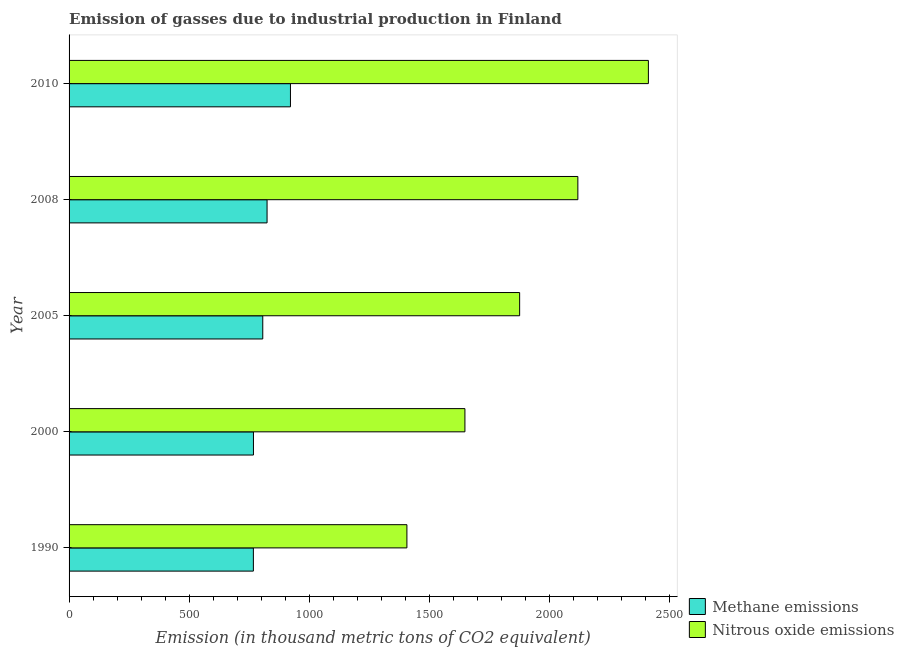How many different coloured bars are there?
Your answer should be compact. 2. How many groups of bars are there?
Your answer should be very brief. 5. Are the number of bars on each tick of the Y-axis equal?
Offer a terse response. Yes. What is the label of the 4th group of bars from the top?
Keep it short and to the point. 2000. What is the amount of methane emissions in 2010?
Offer a very short reply. 921.9. Across all years, what is the maximum amount of methane emissions?
Your answer should be very brief. 921.9. Across all years, what is the minimum amount of nitrous oxide emissions?
Your response must be concise. 1406.8. What is the total amount of nitrous oxide emissions in the graph?
Your response must be concise. 9462.6. What is the difference between the amount of methane emissions in 2000 and that in 2010?
Provide a short and direct response. -154.1. What is the difference between the amount of methane emissions in 2000 and the amount of nitrous oxide emissions in 2008?
Provide a succinct answer. -1350.9. What is the average amount of methane emissions per year?
Ensure brevity in your answer.  817.66. In the year 2008, what is the difference between the amount of nitrous oxide emissions and amount of methane emissions?
Keep it short and to the point. 1294.2. Is the amount of nitrous oxide emissions in 1990 less than that in 2008?
Offer a very short reply. Yes. Is the difference between the amount of methane emissions in 1990 and 2008 greater than the difference between the amount of nitrous oxide emissions in 1990 and 2008?
Give a very brief answer. Yes. What is the difference between the highest and the second highest amount of nitrous oxide emissions?
Your answer should be compact. 293.7. What is the difference between the highest and the lowest amount of methane emissions?
Give a very brief answer. 154.4. What does the 2nd bar from the top in 2008 represents?
Make the answer very short. Methane emissions. What does the 1st bar from the bottom in 2010 represents?
Offer a very short reply. Methane emissions. How many years are there in the graph?
Your answer should be compact. 5. Does the graph contain grids?
Give a very brief answer. No. Where does the legend appear in the graph?
Ensure brevity in your answer.  Bottom right. How are the legend labels stacked?
Your answer should be compact. Vertical. What is the title of the graph?
Offer a very short reply. Emission of gasses due to industrial production in Finland. What is the label or title of the X-axis?
Your response must be concise. Emission (in thousand metric tons of CO2 equivalent). What is the Emission (in thousand metric tons of CO2 equivalent) in Methane emissions in 1990?
Ensure brevity in your answer.  767.5. What is the Emission (in thousand metric tons of CO2 equivalent) in Nitrous oxide emissions in 1990?
Provide a succinct answer. 1406.8. What is the Emission (in thousand metric tons of CO2 equivalent) in Methane emissions in 2000?
Ensure brevity in your answer.  767.8. What is the Emission (in thousand metric tons of CO2 equivalent) of Nitrous oxide emissions in 2000?
Offer a very short reply. 1648.4. What is the Emission (in thousand metric tons of CO2 equivalent) of Methane emissions in 2005?
Provide a succinct answer. 806.6. What is the Emission (in thousand metric tons of CO2 equivalent) in Nitrous oxide emissions in 2005?
Your response must be concise. 1876.3. What is the Emission (in thousand metric tons of CO2 equivalent) of Methane emissions in 2008?
Provide a succinct answer. 824.5. What is the Emission (in thousand metric tons of CO2 equivalent) of Nitrous oxide emissions in 2008?
Offer a very short reply. 2118.7. What is the Emission (in thousand metric tons of CO2 equivalent) of Methane emissions in 2010?
Ensure brevity in your answer.  921.9. What is the Emission (in thousand metric tons of CO2 equivalent) of Nitrous oxide emissions in 2010?
Your response must be concise. 2412.4. Across all years, what is the maximum Emission (in thousand metric tons of CO2 equivalent) in Methane emissions?
Ensure brevity in your answer.  921.9. Across all years, what is the maximum Emission (in thousand metric tons of CO2 equivalent) in Nitrous oxide emissions?
Offer a very short reply. 2412.4. Across all years, what is the minimum Emission (in thousand metric tons of CO2 equivalent) of Methane emissions?
Make the answer very short. 767.5. Across all years, what is the minimum Emission (in thousand metric tons of CO2 equivalent) of Nitrous oxide emissions?
Keep it short and to the point. 1406.8. What is the total Emission (in thousand metric tons of CO2 equivalent) of Methane emissions in the graph?
Make the answer very short. 4088.3. What is the total Emission (in thousand metric tons of CO2 equivalent) in Nitrous oxide emissions in the graph?
Your response must be concise. 9462.6. What is the difference between the Emission (in thousand metric tons of CO2 equivalent) of Nitrous oxide emissions in 1990 and that in 2000?
Offer a very short reply. -241.6. What is the difference between the Emission (in thousand metric tons of CO2 equivalent) in Methane emissions in 1990 and that in 2005?
Give a very brief answer. -39.1. What is the difference between the Emission (in thousand metric tons of CO2 equivalent) of Nitrous oxide emissions in 1990 and that in 2005?
Offer a terse response. -469.5. What is the difference between the Emission (in thousand metric tons of CO2 equivalent) in Methane emissions in 1990 and that in 2008?
Offer a very short reply. -57. What is the difference between the Emission (in thousand metric tons of CO2 equivalent) of Nitrous oxide emissions in 1990 and that in 2008?
Your answer should be compact. -711.9. What is the difference between the Emission (in thousand metric tons of CO2 equivalent) of Methane emissions in 1990 and that in 2010?
Provide a short and direct response. -154.4. What is the difference between the Emission (in thousand metric tons of CO2 equivalent) in Nitrous oxide emissions in 1990 and that in 2010?
Offer a terse response. -1005.6. What is the difference between the Emission (in thousand metric tons of CO2 equivalent) of Methane emissions in 2000 and that in 2005?
Offer a very short reply. -38.8. What is the difference between the Emission (in thousand metric tons of CO2 equivalent) of Nitrous oxide emissions in 2000 and that in 2005?
Ensure brevity in your answer.  -227.9. What is the difference between the Emission (in thousand metric tons of CO2 equivalent) in Methane emissions in 2000 and that in 2008?
Make the answer very short. -56.7. What is the difference between the Emission (in thousand metric tons of CO2 equivalent) of Nitrous oxide emissions in 2000 and that in 2008?
Offer a terse response. -470.3. What is the difference between the Emission (in thousand metric tons of CO2 equivalent) of Methane emissions in 2000 and that in 2010?
Make the answer very short. -154.1. What is the difference between the Emission (in thousand metric tons of CO2 equivalent) in Nitrous oxide emissions in 2000 and that in 2010?
Your response must be concise. -764. What is the difference between the Emission (in thousand metric tons of CO2 equivalent) in Methane emissions in 2005 and that in 2008?
Offer a very short reply. -17.9. What is the difference between the Emission (in thousand metric tons of CO2 equivalent) in Nitrous oxide emissions in 2005 and that in 2008?
Provide a short and direct response. -242.4. What is the difference between the Emission (in thousand metric tons of CO2 equivalent) of Methane emissions in 2005 and that in 2010?
Your answer should be very brief. -115.3. What is the difference between the Emission (in thousand metric tons of CO2 equivalent) of Nitrous oxide emissions in 2005 and that in 2010?
Offer a very short reply. -536.1. What is the difference between the Emission (in thousand metric tons of CO2 equivalent) in Methane emissions in 2008 and that in 2010?
Give a very brief answer. -97.4. What is the difference between the Emission (in thousand metric tons of CO2 equivalent) in Nitrous oxide emissions in 2008 and that in 2010?
Offer a very short reply. -293.7. What is the difference between the Emission (in thousand metric tons of CO2 equivalent) in Methane emissions in 1990 and the Emission (in thousand metric tons of CO2 equivalent) in Nitrous oxide emissions in 2000?
Make the answer very short. -880.9. What is the difference between the Emission (in thousand metric tons of CO2 equivalent) in Methane emissions in 1990 and the Emission (in thousand metric tons of CO2 equivalent) in Nitrous oxide emissions in 2005?
Make the answer very short. -1108.8. What is the difference between the Emission (in thousand metric tons of CO2 equivalent) in Methane emissions in 1990 and the Emission (in thousand metric tons of CO2 equivalent) in Nitrous oxide emissions in 2008?
Give a very brief answer. -1351.2. What is the difference between the Emission (in thousand metric tons of CO2 equivalent) of Methane emissions in 1990 and the Emission (in thousand metric tons of CO2 equivalent) of Nitrous oxide emissions in 2010?
Provide a short and direct response. -1644.9. What is the difference between the Emission (in thousand metric tons of CO2 equivalent) of Methane emissions in 2000 and the Emission (in thousand metric tons of CO2 equivalent) of Nitrous oxide emissions in 2005?
Offer a very short reply. -1108.5. What is the difference between the Emission (in thousand metric tons of CO2 equivalent) in Methane emissions in 2000 and the Emission (in thousand metric tons of CO2 equivalent) in Nitrous oxide emissions in 2008?
Your answer should be very brief. -1350.9. What is the difference between the Emission (in thousand metric tons of CO2 equivalent) of Methane emissions in 2000 and the Emission (in thousand metric tons of CO2 equivalent) of Nitrous oxide emissions in 2010?
Make the answer very short. -1644.6. What is the difference between the Emission (in thousand metric tons of CO2 equivalent) in Methane emissions in 2005 and the Emission (in thousand metric tons of CO2 equivalent) in Nitrous oxide emissions in 2008?
Provide a short and direct response. -1312.1. What is the difference between the Emission (in thousand metric tons of CO2 equivalent) in Methane emissions in 2005 and the Emission (in thousand metric tons of CO2 equivalent) in Nitrous oxide emissions in 2010?
Your answer should be compact. -1605.8. What is the difference between the Emission (in thousand metric tons of CO2 equivalent) in Methane emissions in 2008 and the Emission (in thousand metric tons of CO2 equivalent) in Nitrous oxide emissions in 2010?
Your answer should be compact. -1587.9. What is the average Emission (in thousand metric tons of CO2 equivalent) of Methane emissions per year?
Offer a very short reply. 817.66. What is the average Emission (in thousand metric tons of CO2 equivalent) of Nitrous oxide emissions per year?
Provide a short and direct response. 1892.52. In the year 1990, what is the difference between the Emission (in thousand metric tons of CO2 equivalent) in Methane emissions and Emission (in thousand metric tons of CO2 equivalent) in Nitrous oxide emissions?
Keep it short and to the point. -639.3. In the year 2000, what is the difference between the Emission (in thousand metric tons of CO2 equivalent) of Methane emissions and Emission (in thousand metric tons of CO2 equivalent) of Nitrous oxide emissions?
Your answer should be very brief. -880.6. In the year 2005, what is the difference between the Emission (in thousand metric tons of CO2 equivalent) of Methane emissions and Emission (in thousand metric tons of CO2 equivalent) of Nitrous oxide emissions?
Provide a short and direct response. -1069.7. In the year 2008, what is the difference between the Emission (in thousand metric tons of CO2 equivalent) of Methane emissions and Emission (in thousand metric tons of CO2 equivalent) of Nitrous oxide emissions?
Your answer should be very brief. -1294.2. In the year 2010, what is the difference between the Emission (in thousand metric tons of CO2 equivalent) of Methane emissions and Emission (in thousand metric tons of CO2 equivalent) of Nitrous oxide emissions?
Your answer should be compact. -1490.5. What is the ratio of the Emission (in thousand metric tons of CO2 equivalent) in Nitrous oxide emissions in 1990 to that in 2000?
Your answer should be compact. 0.85. What is the ratio of the Emission (in thousand metric tons of CO2 equivalent) of Methane emissions in 1990 to that in 2005?
Your answer should be compact. 0.95. What is the ratio of the Emission (in thousand metric tons of CO2 equivalent) of Nitrous oxide emissions in 1990 to that in 2005?
Keep it short and to the point. 0.75. What is the ratio of the Emission (in thousand metric tons of CO2 equivalent) in Methane emissions in 1990 to that in 2008?
Offer a very short reply. 0.93. What is the ratio of the Emission (in thousand metric tons of CO2 equivalent) in Nitrous oxide emissions in 1990 to that in 2008?
Make the answer very short. 0.66. What is the ratio of the Emission (in thousand metric tons of CO2 equivalent) in Methane emissions in 1990 to that in 2010?
Provide a short and direct response. 0.83. What is the ratio of the Emission (in thousand metric tons of CO2 equivalent) of Nitrous oxide emissions in 1990 to that in 2010?
Provide a short and direct response. 0.58. What is the ratio of the Emission (in thousand metric tons of CO2 equivalent) of Methane emissions in 2000 to that in 2005?
Ensure brevity in your answer.  0.95. What is the ratio of the Emission (in thousand metric tons of CO2 equivalent) in Nitrous oxide emissions in 2000 to that in 2005?
Provide a succinct answer. 0.88. What is the ratio of the Emission (in thousand metric tons of CO2 equivalent) of Methane emissions in 2000 to that in 2008?
Provide a short and direct response. 0.93. What is the ratio of the Emission (in thousand metric tons of CO2 equivalent) of Nitrous oxide emissions in 2000 to that in 2008?
Make the answer very short. 0.78. What is the ratio of the Emission (in thousand metric tons of CO2 equivalent) of Methane emissions in 2000 to that in 2010?
Ensure brevity in your answer.  0.83. What is the ratio of the Emission (in thousand metric tons of CO2 equivalent) of Nitrous oxide emissions in 2000 to that in 2010?
Your answer should be compact. 0.68. What is the ratio of the Emission (in thousand metric tons of CO2 equivalent) in Methane emissions in 2005 to that in 2008?
Keep it short and to the point. 0.98. What is the ratio of the Emission (in thousand metric tons of CO2 equivalent) in Nitrous oxide emissions in 2005 to that in 2008?
Give a very brief answer. 0.89. What is the ratio of the Emission (in thousand metric tons of CO2 equivalent) in Methane emissions in 2005 to that in 2010?
Provide a short and direct response. 0.87. What is the ratio of the Emission (in thousand metric tons of CO2 equivalent) in Nitrous oxide emissions in 2005 to that in 2010?
Ensure brevity in your answer.  0.78. What is the ratio of the Emission (in thousand metric tons of CO2 equivalent) of Methane emissions in 2008 to that in 2010?
Your answer should be compact. 0.89. What is the ratio of the Emission (in thousand metric tons of CO2 equivalent) in Nitrous oxide emissions in 2008 to that in 2010?
Your answer should be very brief. 0.88. What is the difference between the highest and the second highest Emission (in thousand metric tons of CO2 equivalent) in Methane emissions?
Provide a short and direct response. 97.4. What is the difference between the highest and the second highest Emission (in thousand metric tons of CO2 equivalent) of Nitrous oxide emissions?
Offer a terse response. 293.7. What is the difference between the highest and the lowest Emission (in thousand metric tons of CO2 equivalent) of Methane emissions?
Offer a very short reply. 154.4. What is the difference between the highest and the lowest Emission (in thousand metric tons of CO2 equivalent) in Nitrous oxide emissions?
Provide a short and direct response. 1005.6. 